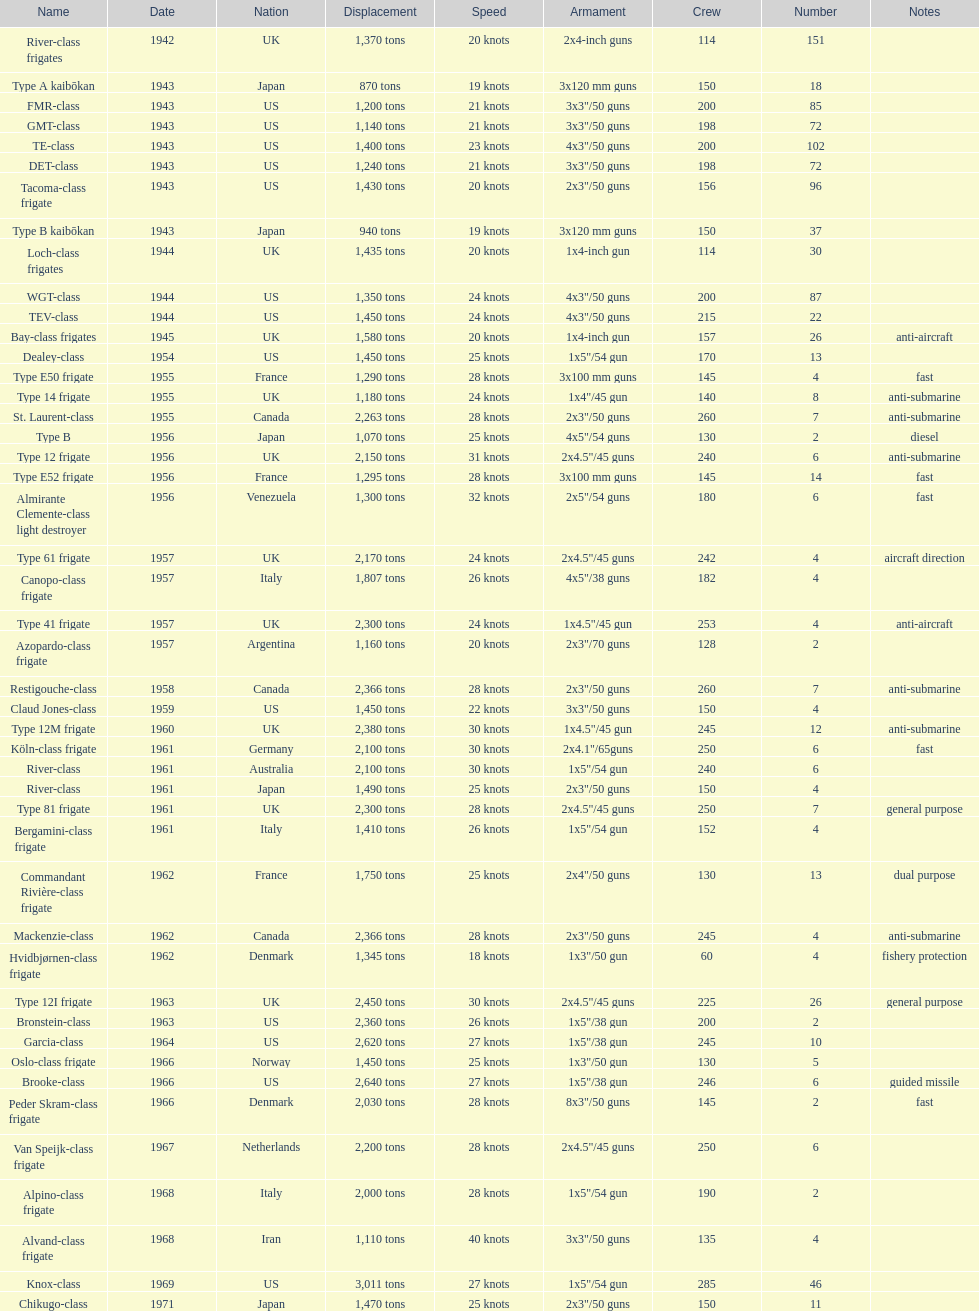Which of the boats listed is the fastest? Alvand-class frigate. 